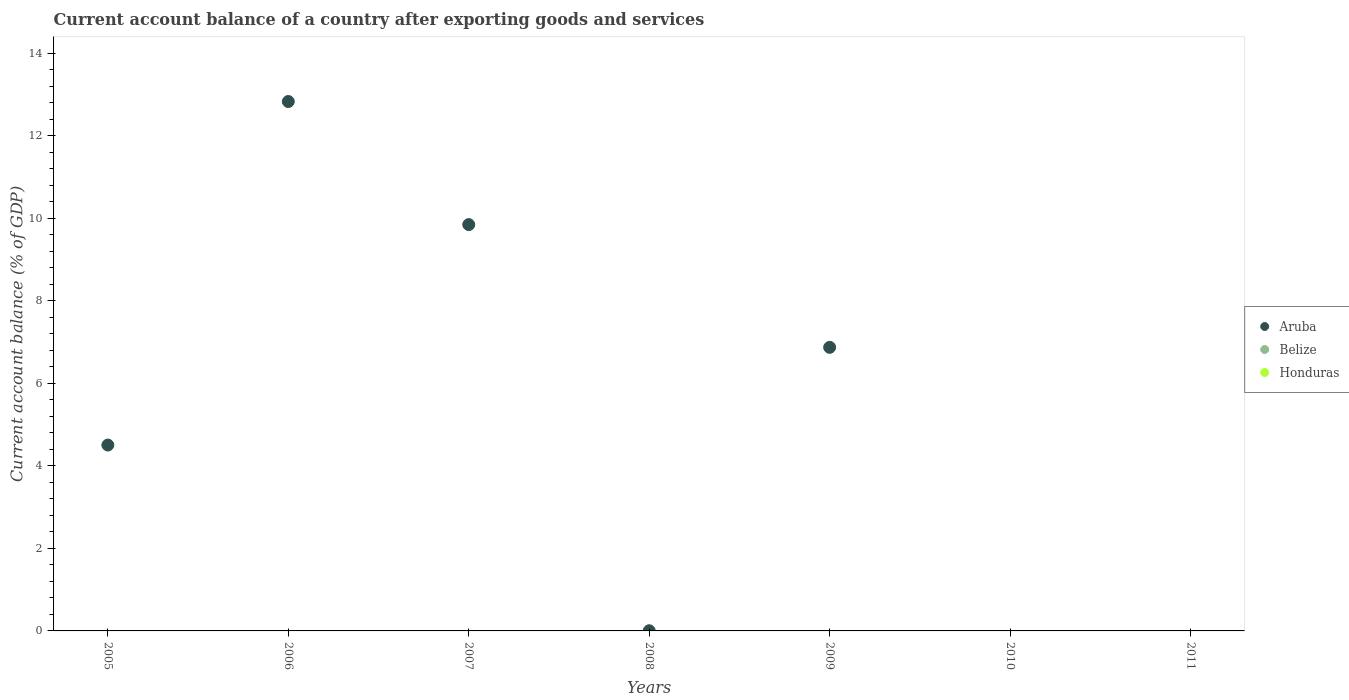How many different coloured dotlines are there?
Keep it short and to the point. 1. Is the number of dotlines equal to the number of legend labels?
Offer a very short reply. No. In which year was the account balance in Aruba maximum?
Ensure brevity in your answer.  2006. What is the difference between the account balance in Aruba in 2008 and that in 2009?
Keep it short and to the point. -6.87. What is the difference between the account balance in Aruba in 2006 and the account balance in Belize in 2008?
Ensure brevity in your answer.  12.83. In how many years, is the account balance in Honduras greater than 10.4 %?
Keep it short and to the point. 0. What is the ratio of the account balance in Aruba in 2006 to that in 2009?
Provide a succinct answer. 1.87. What is the difference between the highest and the second highest account balance in Aruba?
Your response must be concise. 2.98. What is the difference between the highest and the lowest account balance in Aruba?
Offer a terse response. 12.83. How many dotlines are there?
Provide a succinct answer. 1. What is the difference between two consecutive major ticks on the Y-axis?
Ensure brevity in your answer.  2. Are the values on the major ticks of Y-axis written in scientific E-notation?
Give a very brief answer. No. Where does the legend appear in the graph?
Make the answer very short. Center right. How many legend labels are there?
Offer a very short reply. 3. What is the title of the graph?
Offer a very short reply. Current account balance of a country after exporting goods and services. Does "Morocco" appear as one of the legend labels in the graph?
Ensure brevity in your answer.  No. What is the label or title of the Y-axis?
Provide a short and direct response. Current account balance (% of GDP). What is the Current account balance (% of GDP) in Aruba in 2005?
Your answer should be compact. 4.5. What is the Current account balance (% of GDP) in Belize in 2005?
Your answer should be very brief. 0. What is the Current account balance (% of GDP) in Honduras in 2005?
Your answer should be compact. 0. What is the Current account balance (% of GDP) in Aruba in 2006?
Provide a short and direct response. 12.83. What is the Current account balance (% of GDP) of Aruba in 2007?
Provide a succinct answer. 9.84. What is the Current account balance (% of GDP) of Aruba in 2008?
Make the answer very short. 0. What is the Current account balance (% of GDP) in Belize in 2008?
Make the answer very short. 0. What is the Current account balance (% of GDP) in Honduras in 2008?
Provide a short and direct response. 0. What is the Current account balance (% of GDP) in Aruba in 2009?
Your response must be concise. 6.87. What is the Current account balance (% of GDP) in Belize in 2009?
Your answer should be compact. 0. What is the Current account balance (% of GDP) in Aruba in 2010?
Your answer should be very brief. 0. What is the Current account balance (% of GDP) in Belize in 2010?
Ensure brevity in your answer.  0. What is the Current account balance (% of GDP) in Honduras in 2010?
Give a very brief answer. 0. What is the Current account balance (% of GDP) in Aruba in 2011?
Make the answer very short. 0. What is the Current account balance (% of GDP) in Belize in 2011?
Your answer should be very brief. 0. What is the Current account balance (% of GDP) of Honduras in 2011?
Your answer should be compact. 0. Across all years, what is the maximum Current account balance (% of GDP) of Aruba?
Provide a succinct answer. 12.83. What is the total Current account balance (% of GDP) in Aruba in the graph?
Make the answer very short. 34.05. What is the total Current account balance (% of GDP) of Honduras in the graph?
Your response must be concise. 0. What is the difference between the Current account balance (% of GDP) in Aruba in 2005 and that in 2006?
Give a very brief answer. -8.32. What is the difference between the Current account balance (% of GDP) of Aruba in 2005 and that in 2007?
Your answer should be very brief. -5.34. What is the difference between the Current account balance (% of GDP) in Aruba in 2005 and that in 2008?
Keep it short and to the point. 4.5. What is the difference between the Current account balance (% of GDP) in Aruba in 2005 and that in 2009?
Provide a short and direct response. -2.37. What is the difference between the Current account balance (% of GDP) in Aruba in 2006 and that in 2007?
Your response must be concise. 2.98. What is the difference between the Current account balance (% of GDP) in Aruba in 2006 and that in 2008?
Your answer should be compact. 12.82. What is the difference between the Current account balance (% of GDP) of Aruba in 2006 and that in 2009?
Make the answer very short. 5.96. What is the difference between the Current account balance (% of GDP) of Aruba in 2007 and that in 2008?
Make the answer very short. 9.84. What is the difference between the Current account balance (% of GDP) in Aruba in 2007 and that in 2009?
Offer a very short reply. 2.97. What is the difference between the Current account balance (% of GDP) of Aruba in 2008 and that in 2009?
Ensure brevity in your answer.  -6.87. What is the average Current account balance (% of GDP) in Aruba per year?
Make the answer very short. 4.86. What is the ratio of the Current account balance (% of GDP) of Aruba in 2005 to that in 2006?
Keep it short and to the point. 0.35. What is the ratio of the Current account balance (% of GDP) in Aruba in 2005 to that in 2007?
Make the answer very short. 0.46. What is the ratio of the Current account balance (% of GDP) of Aruba in 2005 to that in 2008?
Ensure brevity in your answer.  1125.19. What is the ratio of the Current account balance (% of GDP) of Aruba in 2005 to that in 2009?
Make the answer very short. 0.66. What is the ratio of the Current account balance (% of GDP) of Aruba in 2006 to that in 2007?
Provide a succinct answer. 1.3. What is the ratio of the Current account balance (% of GDP) in Aruba in 2006 to that in 2008?
Provide a succinct answer. 3204.73. What is the ratio of the Current account balance (% of GDP) in Aruba in 2006 to that in 2009?
Ensure brevity in your answer.  1.87. What is the ratio of the Current account balance (% of GDP) of Aruba in 2007 to that in 2008?
Ensure brevity in your answer.  2459.71. What is the ratio of the Current account balance (% of GDP) of Aruba in 2007 to that in 2009?
Keep it short and to the point. 1.43. What is the ratio of the Current account balance (% of GDP) in Aruba in 2008 to that in 2009?
Offer a very short reply. 0. What is the difference between the highest and the second highest Current account balance (% of GDP) in Aruba?
Your response must be concise. 2.98. What is the difference between the highest and the lowest Current account balance (% of GDP) in Aruba?
Give a very brief answer. 12.83. 